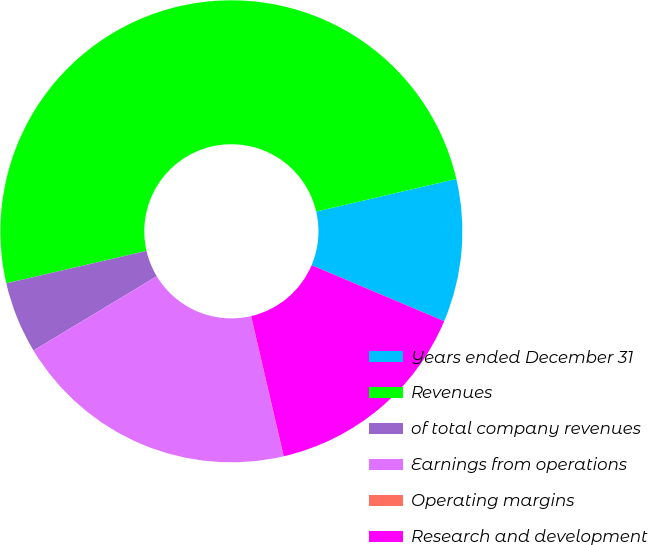<chart> <loc_0><loc_0><loc_500><loc_500><pie_chart><fcel>Years ended December 31<fcel>Revenues<fcel>of total company revenues<fcel>Earnings from operations<fcel>Operating margins<fcel>Research and development<nl><fcel>10.0%<fcel>49.98%<fcel>5.01%<fcel>20.0%<fcel>0.01%<fcel>15.0%<nl></chart> 